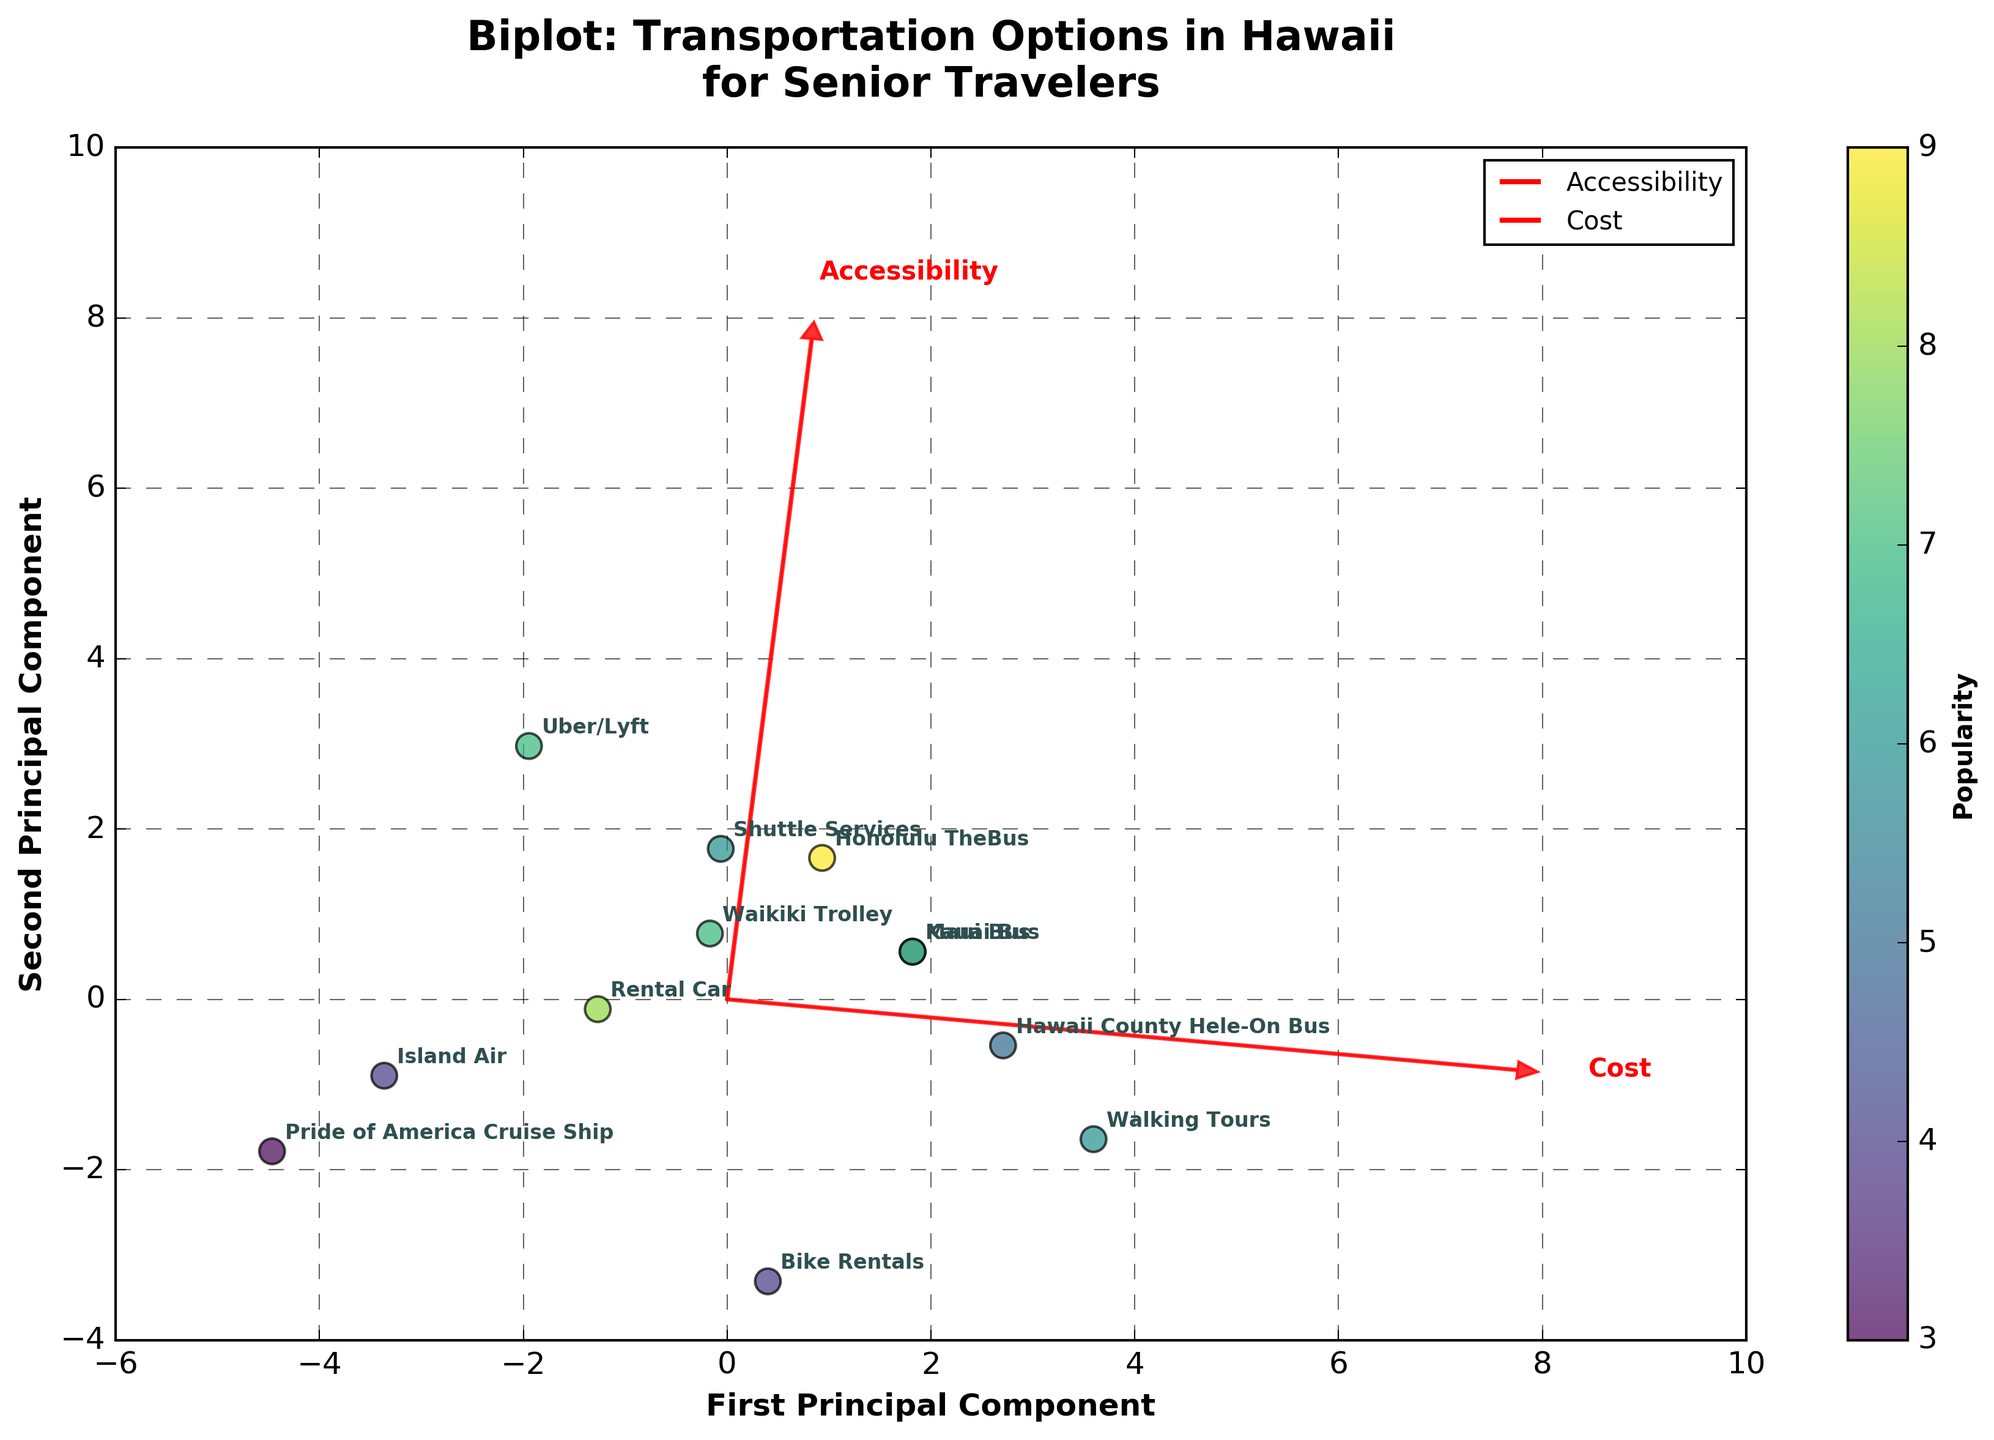What is the title of the plot? The title can be found at the top of the plot. It gives an overview of the plot's purpose.
Answer: Biplot: Transportation Options in Hawaii for Senior Travelers How many transportation options are analyzed in the plot? Count the number of data points (circles) visible in the plot. Each circle represents a transportation option.
Answer: 12 Which transportation option has the highest Accessibility? Observe the position in the direction labeled "Accessibility". The further along that direction, the higher the value.
Answer: Uber/Lyft Which transportation option has the highest Cost? Observe the position in the direction labeled "Cost". The further along that direction, the higher the value.
Answer: Honolulu TheBus What are the axes labeled in the plot? Look at the textual labels on both the horizontal and vertical axes to identify them.
Answer: First Principal Component and Second Principal Component Which transportation options are most similar in terms of both Accessibility and Cost? Look for clusters of points that are close together in both first and second principal component directions.
Answer: Maui Bus and Kauai Bus Which two transportation options have the largest difference in Cost? Compare positions in the direction of the "Cost" feature vector, checking for the widest distance between points along that vector.
Answer: Honolulu TheBus and Pride of America Cruise Ship Which transportation option is most balanced in terms of Accessibility and Cost for senior travelers? Look for points that are relatively centered between the "Accessibility" and "Cost" feature vectors. Evaluate the ones closest to the intersection of these vectors.
Answer: Shuttle Services What does the color variation in the plot represent? Examine the color gradient and its corresponding label or color bar in the plot.
Answer: Popularity How is the popularity of transportation options visually represented? Identify any use of color, size, or annotations that might correspond with the popularity attribute. In this case, examine the color gradient applied to the points.
Answer: By the color gradient on the points 